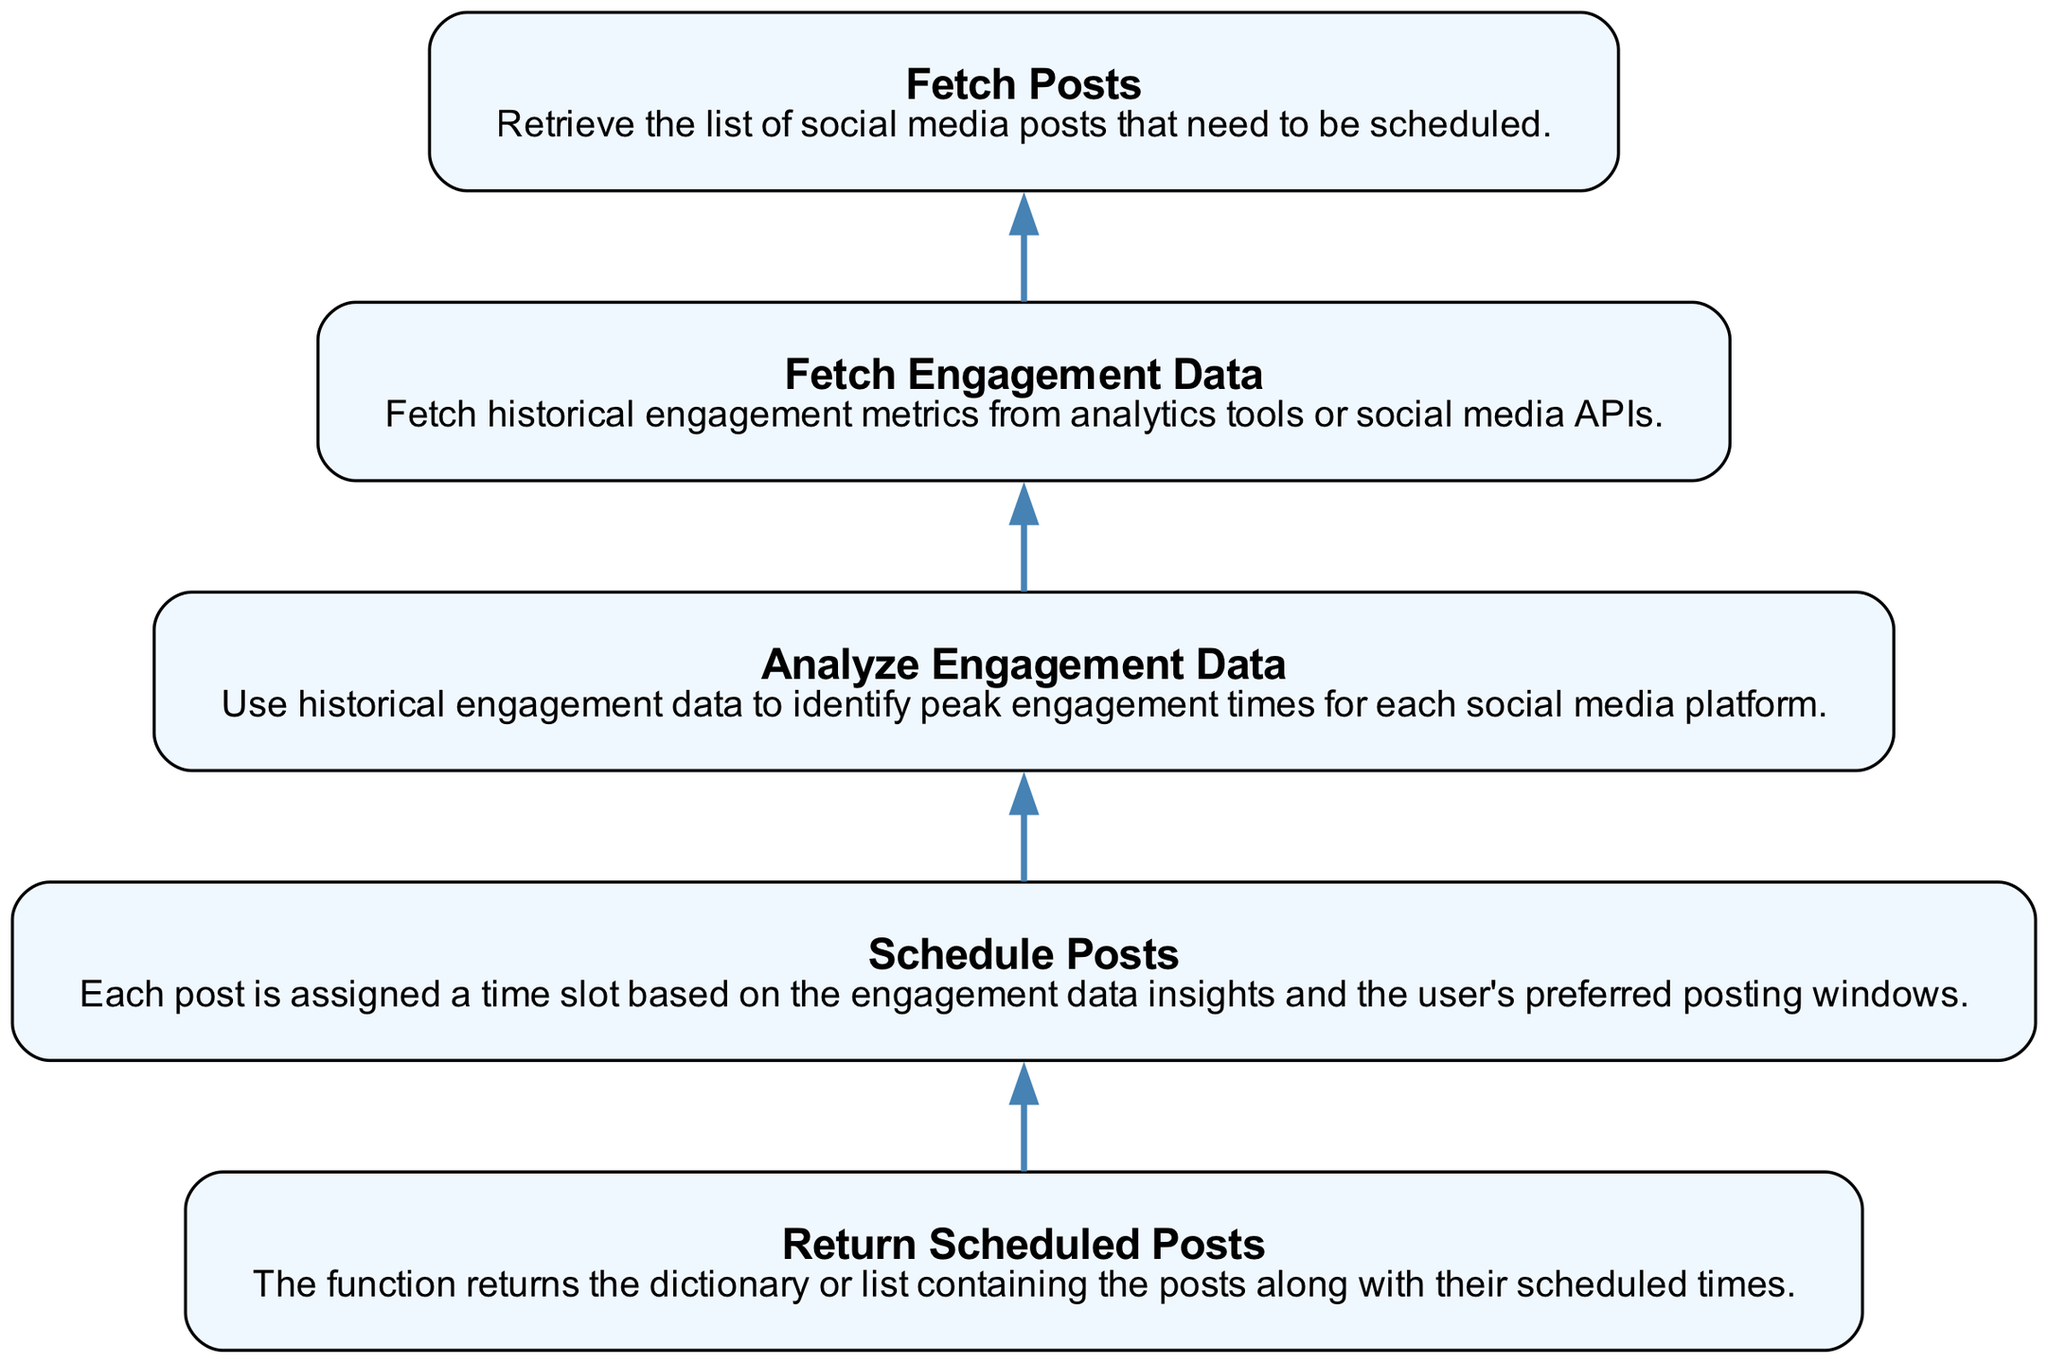What is the final output of the function? The final node, representing the return value of the function, indicates that it will return the scheduled posts. This means after all the processes are complete, the output will be the posts scheduled with their respective times.
Answer: The scheduled posts How many nodes are present in the diagram? By counting each of the listed elements in the diagram, we can identify that there are five nodes. Each node corresponds to a step in the process of scheduling posts.
Answer: Five What is the relationship between "Analyze Engagement Data" and "Schedule Posts"? The edge connecting these two nodes indicates that the analysis of engagement data is a prerequisite or necessary step before scheduling the posts, showing a sequential relationship where one leads to the other.
Answer: Sequential relationship What data is fetched in the second step? The second step involves fetching engagement data, specifically historical engagement metrics from analytics tools or social media APIs, which is essential for analyzing when to post.
Answer: Engagement data Which step comes after "Fetch Posts"? The diagram clearly outlines the flow, and "Analyze Engagement Data" is the next step that follows after "Fetch Posts". This indicates that once the posts are retrieved, engagement data must be analyzed.
Answer: Analyze Engagement Data What does the "Fetch Engagement Data" step utilize? The description reveals that this step uses historical engagement metrics obtained from analytics tools or social media APIs to carry out its function, implying the dependency on prior data sources.
Answer: Historical engagement metrics What is the purpose of the "Schedule Posts" node? This node is crucial as it signifies the action of assigning time slots for the posts based on insights gained from the engagement data analysis and user preferences. It determines when each post should be published.
Answer: Assign time slots What is the starting point of the flowchart? The flowchart begins with the "Fetch Posts" node, which serves as the initial action in the series of steps leading to the scheduling of posts, setting the process in motion.
Answer: Fetch Posts Which node provides insights before scheduling posts? The "Analyze Engagement Data" node provides the necessary insights by evaluating historical engagement data to determine optimal posting times before proceeding to the scheduling of posts.
Answer: Analyze Engagement Data 